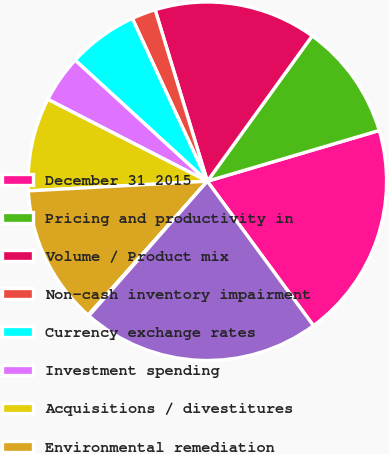Convert chart. <chart><loc_0><loc_0><loc_500><loc_500><pie_chart><fcel>December 31 2015<fcel>Pricing and productivity in<fcel>Volume / Product mix<fcel>Non-cash inventory impairment<fcel>Currency exchange rates<fcel>Investment spending<fcel>Acquisitions / divestitures<fcel>Environmental remediation<fcel>Restructuring / acquisition<fcel>December 31 2016<nl><fcel>19.49%<fcel>10.49%<fcel>14.65%<fcel>2.17%<fcel>6.33%<fcel>4.25%<fcel>8.41%<fcel>12.57%<fcel>0.09%<fcel>21.57%<nl></chart> 